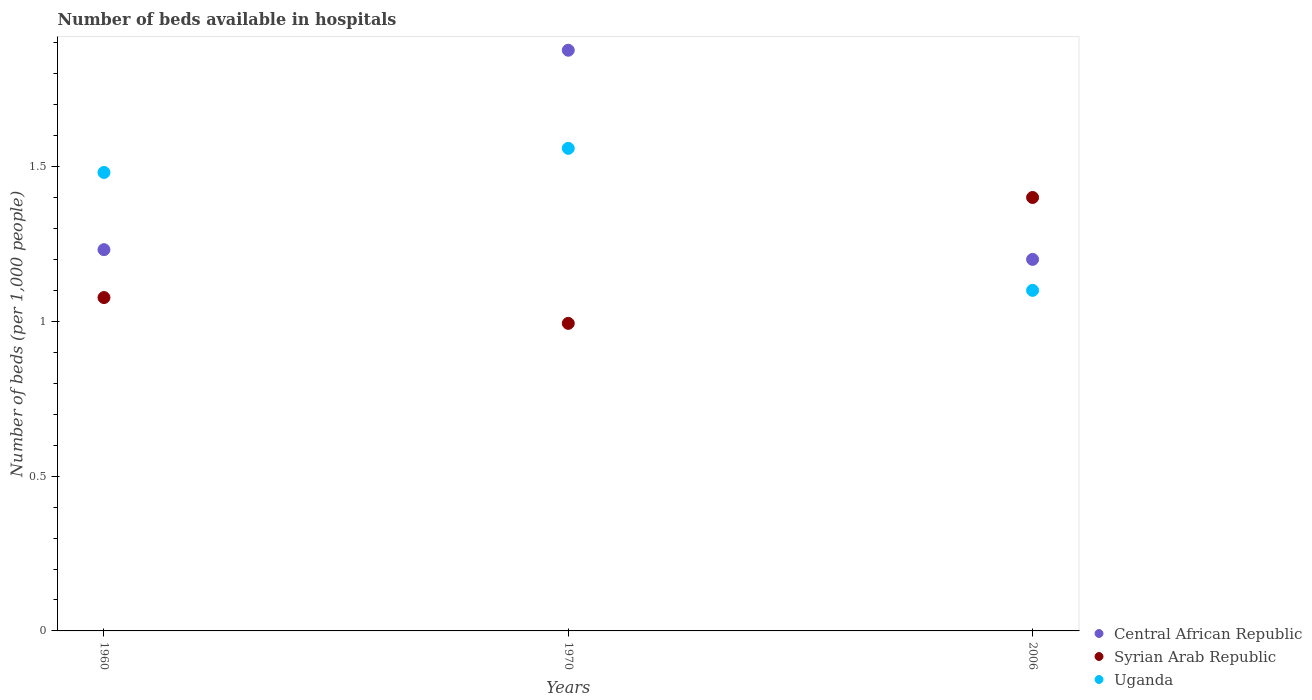What is the number of beds in the hospiatls of in Central African Republic in 1970?
Make the answer very short. 1.88. Across all years, what is the maximum number of beds in the hospiatls of in Central African Republic?
Your response must be concise. 1.88. Across all years, what is the minimum number of beds in the hospiatls of in Syrian Arab Republic?
Offer a terse response. 0.99. In which year was the number of beds in the hospiatls of in Syrian Arab Republic minimum?
Give a very brief answer. 1970. What is the total number of beds in the hospiatls of in Syrian Arab Republic in the graph?
Your response must be concise. 3.47. What is the difference between the number of beds in the hospiatls of in Uganda in 1960 and that in 1970?
Provide a succinct answer. -0.08. What is the difference between the number of beds in the hospiatls of in Uganda in 2006 and the number of beds in the hospiatls of in Central African Republic in 1960?
Offer a very short reply. -0.13. What is the average number of beds in the hospiatls of in Central African Republic per year?
Offer a very short reply. 1.44. In the year 1970, what is the difference between the number of beds in the hospiatls of in Syrian Arab Republic and number of beds in the hospiatls of in Central African Republic?
Keep it short and to the point. -0.88. In how many years, is the number of beds in the hospiatls of in Syrian Arab Republic greater than 1.1?
Keep it short and to the point. 1. What is the ratio of the number of beds in the hospiatls of in Uganda in 1960 to that in 2006?
Provide a short and direct response. 1.35. Is the number of beds in the hospiatls of in Syrian Arab Republic in 1960 less than that in 1970?
Your response must be concise. No. Is the difference between the number of beds in the hospiatls of in Syrian Arab Republic in 1960 and 1970 greater than the difference between the number of beds in the hospiatls of in Central African Republic in 1960 and 1970?
Offer a very short reply. Yes. What is the difference between the highest and the second highest number of beds in the hospiatls of in Syrian Arab Republic?
Keep it short and to the point. 0.32. What is the difference between the highest and the lowest number of beds in the hospiatls of in Central African Republic?
Provide a succinct answer. 0.68. In how many years, is the number of beds in the hospiatls of in Uganda greater than the average number of beds in the hospiatls of in Uganda taken over all years?
Ensure brevity in your answer.  2. Does the number of beds in the hospiatls of in Syrian Arab Republic monotonically increase over the years?
Give a very brief answer. No. Is the number of beds in the hospiatls of in Central African Republic strictly less than the number of beds in the hospiatls of in Uganda over the years?
Your answer should be very brief. No. Are the values on the major ticks of Y-axis written in scientific E-notation?
Your answer should be compact. No. How many legend labels are there?
Ensure brevity in your answer.  3. What is the title of the graph?
Provide a succinct answer. Number of beds available in hospitals. Does "Montenegro" appear as one of the legend labels in the graph?
Make the answer very short. No. What is the label or title of the Y-axis?
Keep it short and to the point. Number of beds (per 1,0 people). What is the Number of beds (per 1,000 people) in Central African Republic in 1960?
Give a very brief answer. 1.23. What is the Number of beds (per 1,000 people) of Syrian Arab Republic in 1960?
Provide a succinct answer. 1.08. What is the Number of beds (per 1,000 people) of Uganda in 1960?
Ensure brevity in your answer.  1.48. What is the Number of beds (per 1,000 people) in Central African Republic in 1970?
Make the answer very short. 1.88. What is the Number of beds (per 1,000 people) in Syrian Arab Republic in 1970?
Give a very brief answer. 0.99. What is the Number of beds (per 1,000 people) in Uganda in 1970?
Provide a short and direct response. 1.56. What is the Number of beds (per 1,000 people) of Uganda in 2006?
Keep it short and to the point. 1.1. Across all years, what is the maximum Number of beds (per 1,000 people) in Central African Republic?
Your response must be concise. 1.88. Across all years, what is the maximum Number of beds (per 1,000 people) of Uganda?
Give a very brief answer. 1.56. Across all years, what is the minimum Number of beds (per 1,000 people) of Syrian Arab Republic?
Make the answer very short. 0.99. What is the total Number of beds (per 1,000 people) in Central African Republic in the graph?
Ensure brevity in your answer.  4.31. What is the total Number of beds (per 1,000 people) in Syrian Arab Republic in the graph?
Your answer should be very brief. 3.47. What is the total Number of beds (per 1,000 people) in Uganda in the graph?
Ensure brevity in your answer.  4.14. What is the difference between the Number of beds (per 1,000 people) in Central African Republic in 1960 and that in 1970?
Ensure brevity in your answer.  -0.64. What is the difference between the Number of beds (per 1,000 people) in Syrian Arab Republic in 1960 and that in 1970?
Offer a terse response. 0.08. What is the difference between the Number of beds (per 1,000 people) of Uganda in 1960 and that in 1970?
Give a very brief answer. -0.08. What is the difference between the Number of beds (per 1,000 people) in Central African Republic in 1960 and that in 2006?
Your answer should be very brief. 0.03. What is the difference between the Number of beds (per 1,000 people) of Syrian Arab Republic in 1960 and that in 2006?
Offer a very short reply. -0.32. What is the difference between the Number of beds (per 1,000 people) of Uganda in 1960 and that in 2006?
Give a very brief answer. 0.38. What is the difference between the Number of beds (per 1,000 people) of Central African Republic in 1970 and that in 2006?
Give a very brief answer. 0.68. What is the difference between the Number of beds (per 1,000 people) in Syrian Arab Republic in 1970 and that in 2006?
Your answer should be compact. -0.41. What is the difference between the Number of beds (per 1,000 people) in Uganda in 1970 and that in 2006?
Give a very brief answer. 0.46. What is the difference between the Number of beds (per 1,000 people) in Central African Republic in 1960 and the Number of beds (per 1,000 people) in Syrian Arab Republic in 1970?
Provide a short and direct response. 0.24. What is the difference between the Number of beds (per 1,000 people) of Central African Republic in 1960 and the Number of beds (per 1,000 people) of Uganda in 1970?
Your response must be concise. -0.33. What is the difference between the Number of beds (per 1,000 people) in Syrian Arab Republic in 1960 and the Number of beds (per 1,000 people) in Uganda in 1970?
Ensure brevity in your answer.  -0.48. What is the difference between the Number of beds (per 1,000 people) of Central African Republic in 1960 and the Number of beds (per 1,000 people) of Syrian Arab Republic in 2006?
Your answer should be compact. -0.17. What is the difference between the Number of beds (per 1,000 people) of Central African Republic in 1960 and the Number of beds (per 1,000 people) of Uganda in 2006?
Provide a succinct answer. 0.13. What is the difference between the Number of beds (per 1,000 people) of Syrian Arab Republic in 1960 and the Number of beds (per 1,000 people) of Uganda in 2006?
Your answer should be compact. -0.02. What is the difference between the Number of beds (per 1,000 people) of Central African Republic in 1970 and the Number of beds (per 1,000 people) of Syrian Arab Republic in 2006?
Provide a short and direct response. 0.48. What is the difference between the Number of beds (per 1,000 people) in Central African Republic in 1970 and the Number of beds (per 1,000 people) in Uganda in 2006?
Offer a terse response. 0.78. What is the difference between the Number of beds (per 1,000 people) in Syrian Arab Republic in 1970 and the Number of beds (per 1,000 people) in Uganda in 2006?
Your answer should be compact. -0.11. What is the average Number of beds (per 1,000 people) in Central African Republic per year?
Provide a short and direct response. 1.44. What is the average Number of beds (per 1,000 people) in Syrian Arab Republic per year?
Give a very brief answer. 1.16. What is the average Number of beds (per 1,000 people) in Uganda per year?
Your answer should be very brief. 1.38. In the year 1960, what is the difference between the Number of beds (per 1,000 people) of Central African Republic and Number of beds (per 1,000 people) of Syrian Arab Republic?
Offer a very short reply. 0.15. In the year 1960, what is the difference between the Number of beds (per 1,000 people) of Central African Republic and Number of beds (per 1,000 people) of Uganda?
Your answer should be compact. -0.25. In the year 1960, what is the difference between the Number of beds (per 1,000 people) in Syrian Arab Republic and Number of beds (per 1,000 people) in Uganda?
Offer a very short reply. -0.4. In the year 1970, what is the difference between the Number of beds (per 1,000 people) in Central African Republic and Number of beds (per 1,000 people) in Syrian Arab Republic?
Offer a very short reply. 0.88. In the year 1970, what is the difference between the Number of beds (per 1,000 people) in Central African Republic and Number of beds (per 1,000 people) in Uganda?
Offer a terse response. 0.32. In the year 1970, what is the difference between the Number of beds (per 1,000 people) of Syrian Arab Republic and Number of beds (per 1,000 people) of Uganda?
Keep it short and to the point. -0.57. In the year 2006, what is the difference between the Number of beds (per 1,000 people) of Central African Republic and Number of beds (per 1,000 people) of Syrian Arab Republic?
Ensure brevity in your answer.  -0.2. In the year 2006, what is the difference between the Number of beds (per 1,000 people) of Central African Republic and Number of beds (per 1,000 people) of Uganda?
Make the answer very short. 0.1. What is the ratio of the Number of beds (per 1,000 people) of Central African Republic in 1960 to that in 1970?
Ensure brevity in your answer.  0.66. What is the ratio of the Number of beds (per 1,000 people) of Syrian Arab Republic in 1960 to that in 1970?
Your answer should be compact. 1.08. What is the ratio of the Number of beds (per 1,000 people) in Central African Republic in 1960 to that in 2006?
Provide a short and direct response. 1.03. What is the ratio of the Number of beds (per 1,000 people) in Syrian Arab Republic in 1960 to that in 2006?
Your response must be concise. 0.77. What is the ratio of the Number of beds (per 1,000 people) of Uganda in 1960 to that in 2006?
Your response must be concise. 1.35. What is the ratio of the Number of beds (per 1,000 people) in Central African Republic in 1970 to that in 2006?
Your answer should be very brief. 1.56. What is the ratio of the Number of beds (per 1,000 people) of Syrian Arab Republic in 1970 to that in 2006?
Your answer should be compact. 0.71. What is the ratio of the Number of beds (per 1,000 people) in Uganda in 1970 to that in 2006?
Provide a short and direct response. 1.42. What is the difference between the highest and the second highest Number of beds (per 1,000 people) of Central African Republic?
Ensure brevity in your answer.  0.64. What is the difference between the highest and the second highest Number of beds (per 1,000 people) of Syrian Arab Republic?
Your answer should be very brief. 0.32. What is the difference between the highest and the second highest Number of beds (per 1,000 people) in Uganda?
Offer a terse response. 0.08. What is the difference between the highest and the lowest Number of beds (per 1,000 people) of Central African Republic?
Provide a short and direct response. 0.68. What is the difference between the highest and the lowest Number of beds (per 1,000 people) in Syrian Arab Republic?
Ensure brevity in your answer.  0.41. What is the difference between the highest and the lowest Number of beds (per 1,000 people) of Uganda?
Provide a short and direct response. 0.46. 